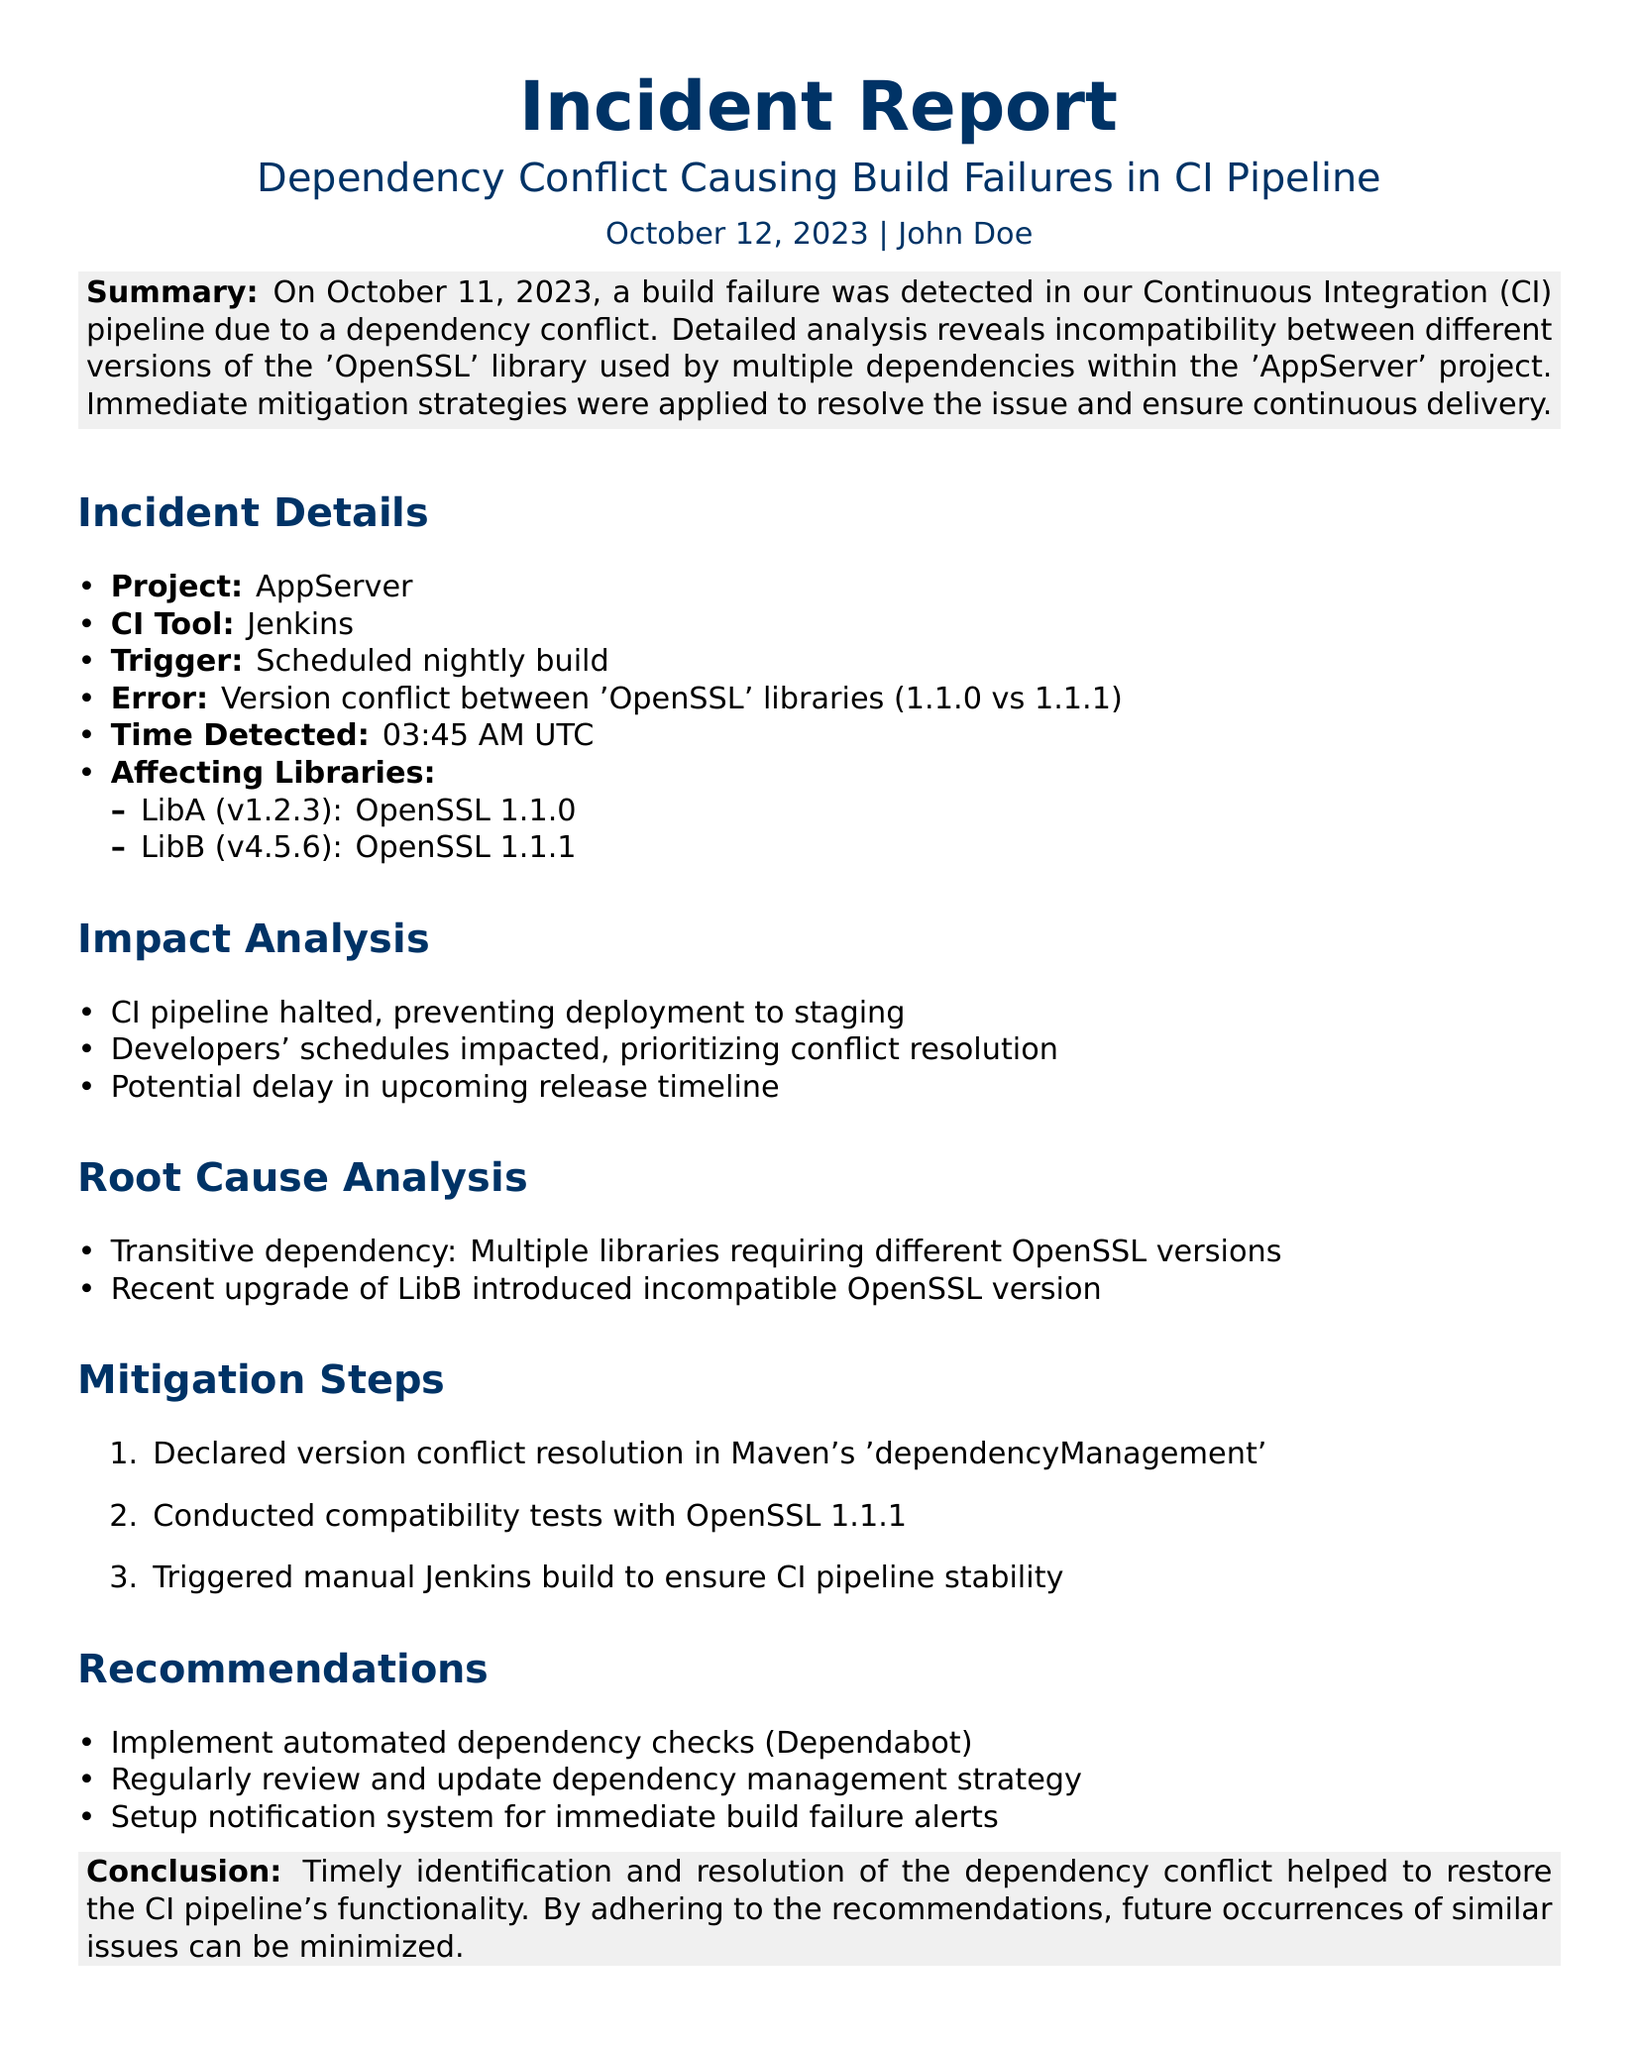What date was the build failure detected? The document states that the build failure was detected on October 11, 2023.
Answer: October 11, 2023 What project is the incident report about? The report specifically mentions the project affected by the incident as 'AppServer'.
Answer: AppServer What CI tool was used for the pipeline? The incident report identifies Jenkins as the CI tool utilized in this situation.
Answer: Jenkins What is the version conflict between the OpenSSL libraries? The conflict is explicitly stated as being between OpenSSL versions 1.1.0 and 1.1.1.
Answer: 1.1.0 vs 1.1.1 What libraries were affected by the dependency conflict? The affected libraries listed in the document are LibA and LibB.
Answer: LibA and LibB What step was taken to manage the version conflict? The report notes that a resolution was declared in Maven's 'dependencyManagement'.
Answer: 'dependencyManagement' What was the time of detection for the build failure? The document specifies that the build failure was detected at 03:45 AM UTC.
Answer: 03:45 AM UTC What is one recommendation made in the report? The report suggests implementing automated dependency checks as a recommendation.
Answer: Automated dependency checks What was the impact on the CI pipeline? The document states that the CI pipeline was halted, preventing deployment to staging.
Answer: Halted 